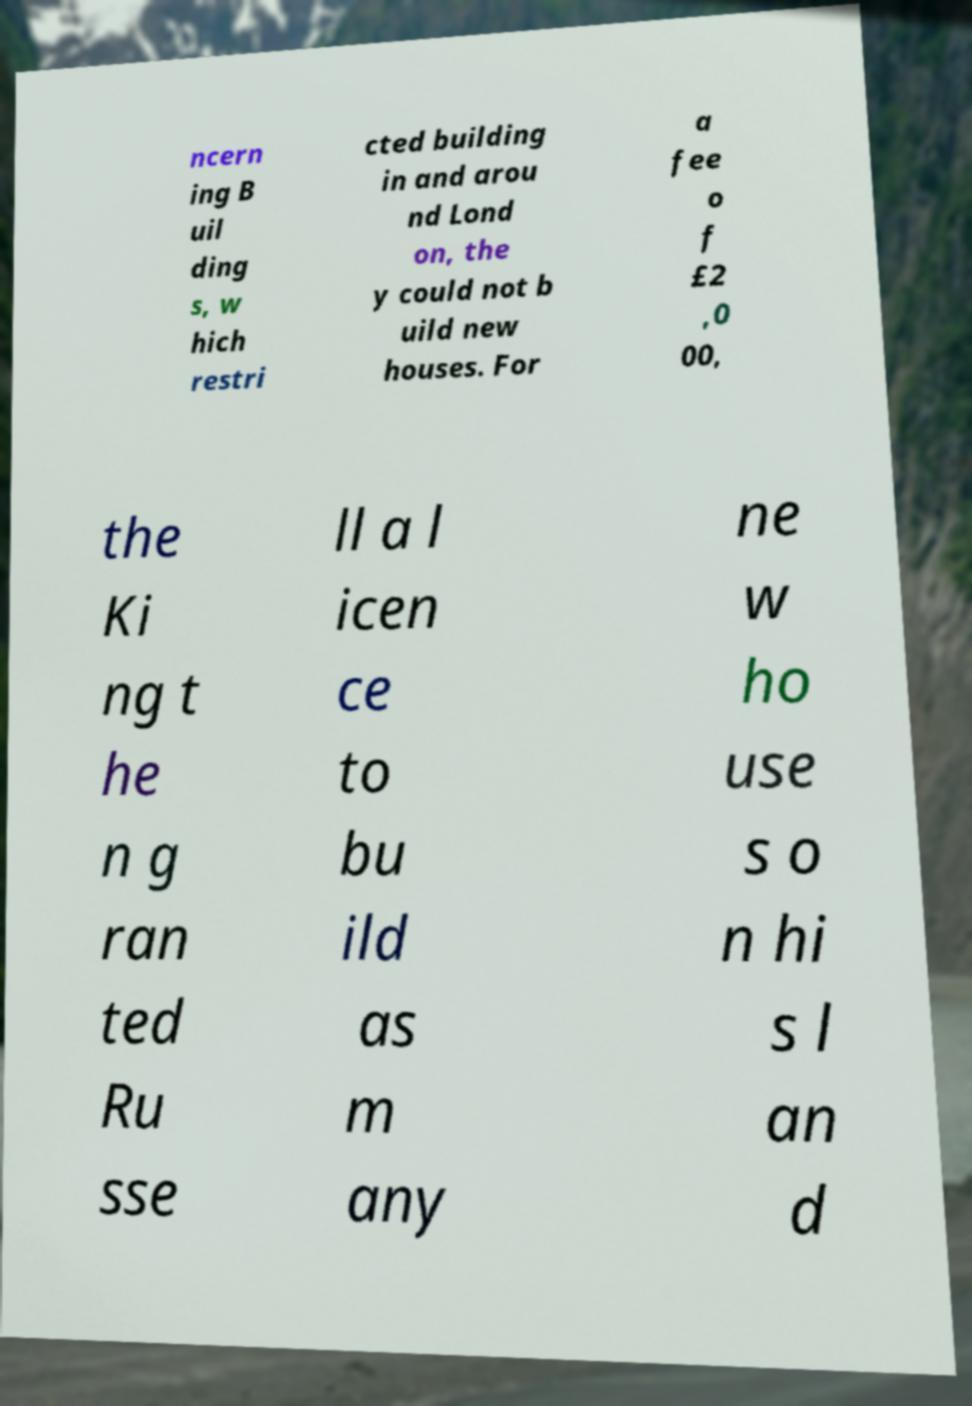For documentation purposes, I need the text within this image transcribed. Could you provide that? ncern ing B uil ding s, w hich restri cted building in and arou nd Lond on, the y could not b uild new houses. For a fee o f £2 ,0 00, the Ki ng t he n g ran ted Ru sse ll a l icen ce to bu ild as m any ne w ho use s o n hi s l an d 